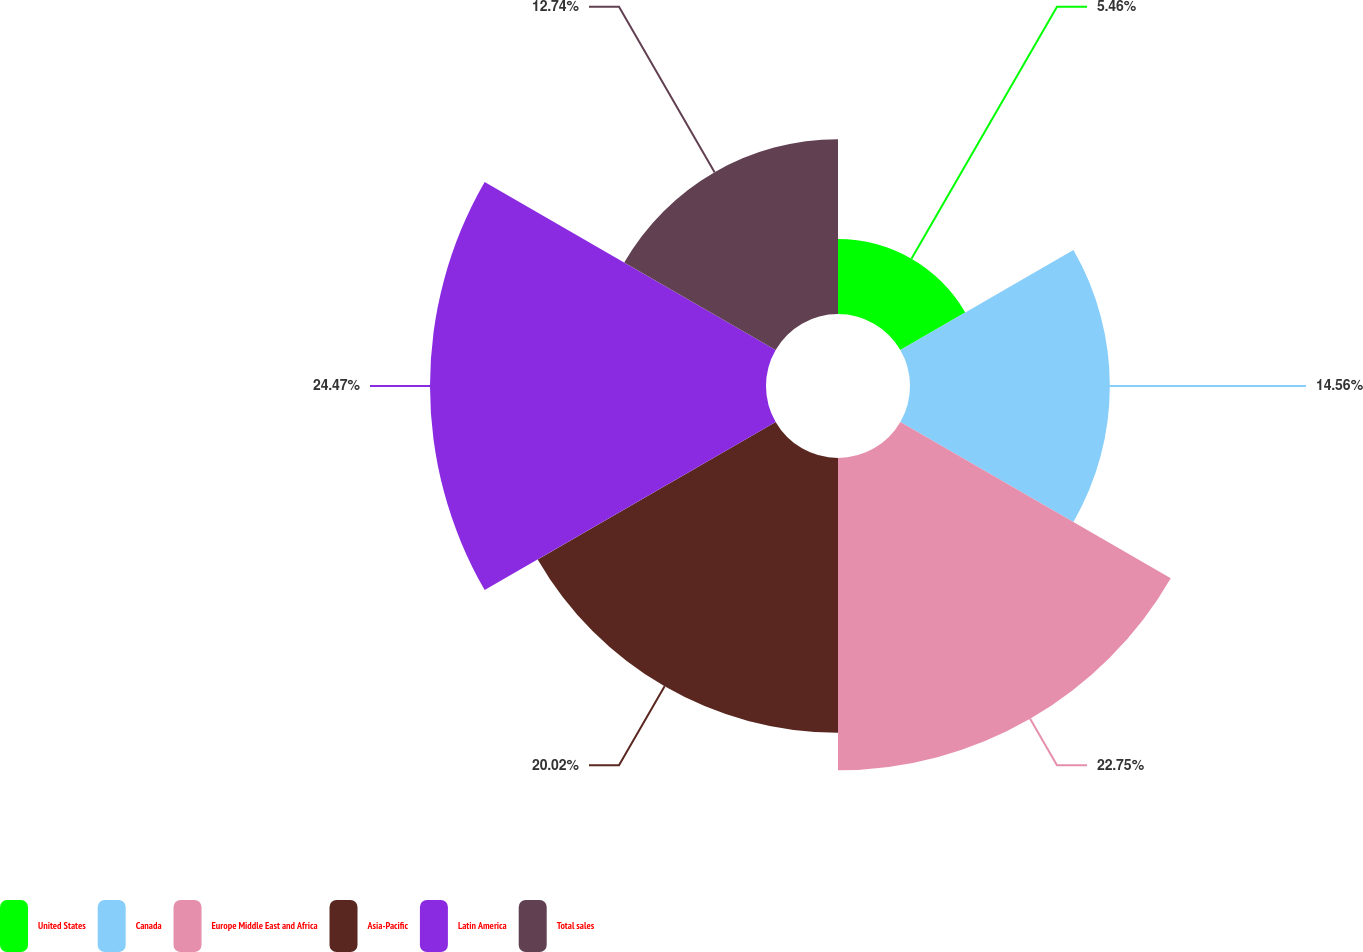<chart> <loc_0><loc_0><loc_500><loc_500><pie_chart><fcel>United States<fcel>Canada<fcel>Europe Middle East and Africa<fcel>Asia-Pacific<fcel>Latin America<fcel>Total sales<nl><fcel>5.46%<fcel>14.56%<fcel>22.75%<fcel>20.02%<fcel>24.48%<fcel>12.74%<nl></chart> 